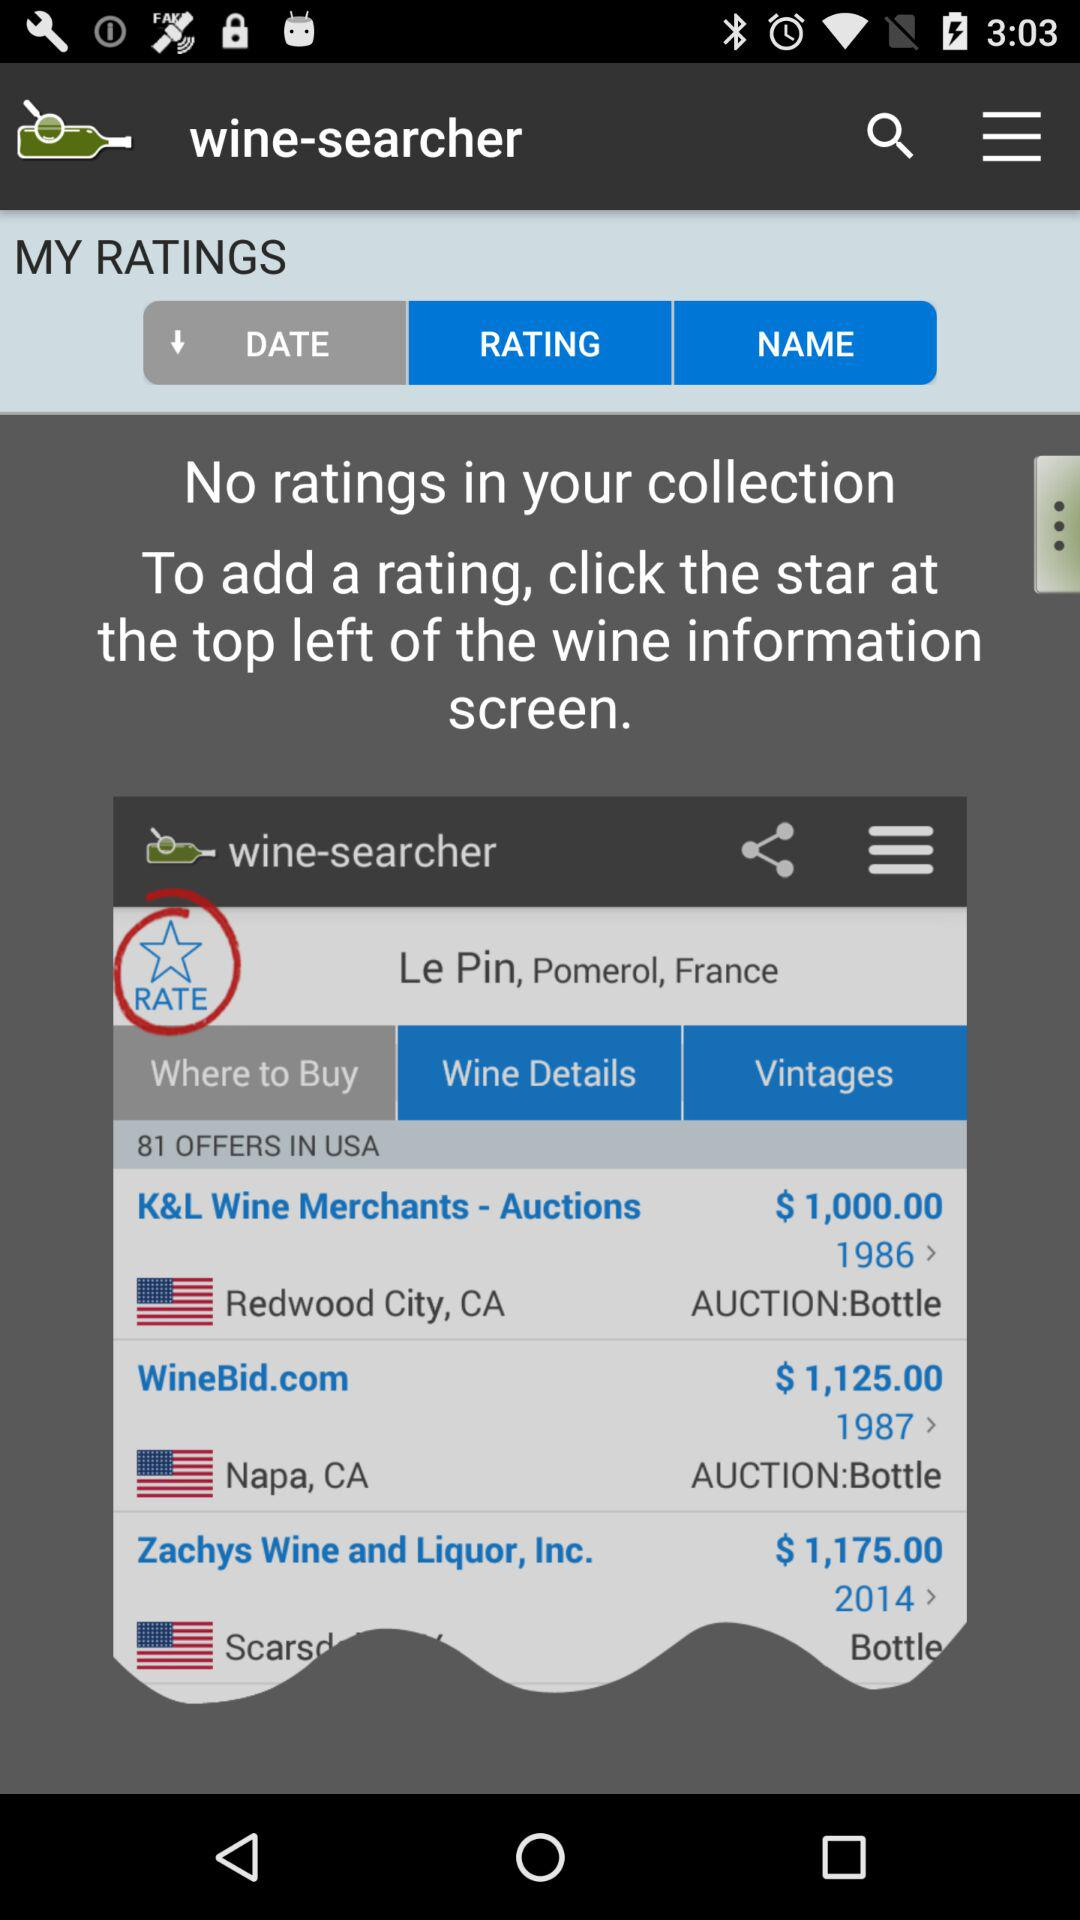How many offers are there in the USA? There are 81 offers in the USA. 